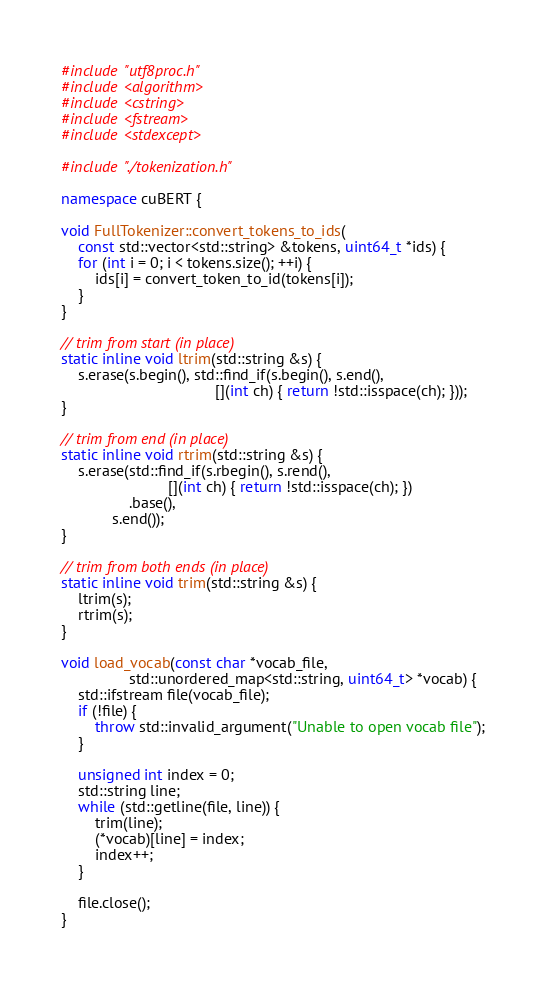<code> <loc_0><loc_0><loc_500><loc_500><_C++_>#include "utf8proc.h"
#include <algorithm>
#include <cstring>
#include <fstream>
#include <stdexcept>

#include "./tokenization.h"

namespace cuBERT {

void FullTokenizer::convert_tokens_to_ids(
    const std::vector<std::string> &tokens, uint64_t *ids) {
    for (int i = 0; i < tokens.size(); ++i) {
        ids[i] = convert_token_to_id(tokens[i]);
    }
}

// trim from start (in place)
static inline void ltrim(std::string &s) {
    s.erase(s.begin(), std::find_if(s.begin(), s.end(),
                                    [](int ch) { return !std::isspace(ch); }));
}

// trim from end (in place)
static inline void rtrim(std::string &s) {
    s.erase(std::find_if(s.rbegin(), s.rend(),
                         [](int ch) { return !std::isspace(ch); })
                .base(),
            s.end());
}

// trim from both ends (in place)
static inline void trim(std::string &s) {
    ltrim(s);
    rtrim(s);
}

void load_vocab(const char *vocab_file,
                std::unordered_map<std::string, uint64_t> *vocab) {
    std::ifstream file(vocab_file);
    if (!file) {
        throw std::invalid_argument("Unable to open vocab file");
    }

    unsigned int index = 0;
    std::string line;
    while (std::getline(file, line)) {
        trim(line);
        (*vocab)[line] = index;
        index++;
    }

    file.close();
}
</code> 